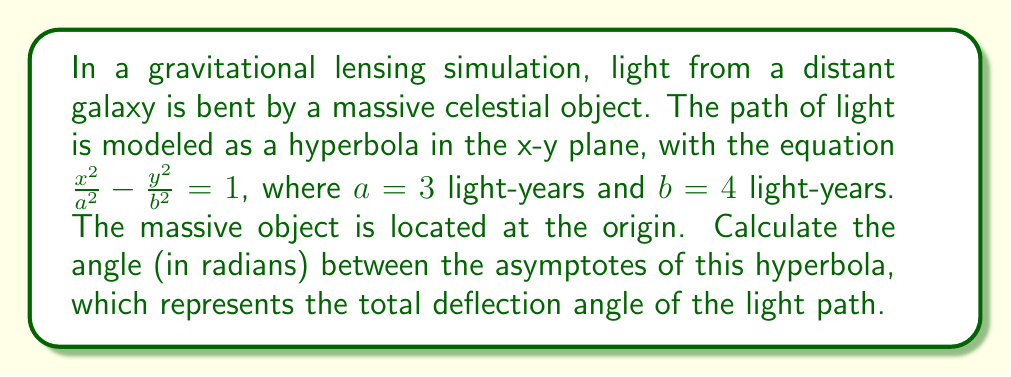Give your solution to this math problem. To solve this problem, we'll follow these steps:

1) The equation of the hyperbola is given as $\frac{x^2}{a^2} - \frac{y^2}{b^2} = 1$, where $a = 3$ and $b = 4$ light-years.

2) For a hyperbola, the angle between the asymptotes is given by the formula:

   $$\theta = 2 \arctan(\frac{b}{a})$$

3) Substituting the values:

   $$\theta = 2 \arctan(\frac{4}{3})$$

4) Calculate the value inside the arctan:
   
   $$\frac{4}{3} \approx 1.3333$$

5) Apply the arctan function:

   $$\arctan(1.3333) \approx 0.9273 \text{ radians}$$

6) Multiply by 2 to get the final result:

   $$\theta = 2 * 0.9273 \approx 1.8546 \text{ radians}$$

This angle represents the total deflection of the light path due to gravitational lensing.
Answer: $1.8546$ radians 